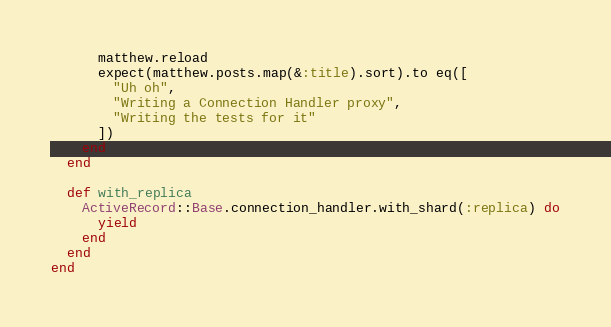<code> <loc_0><loc_0><loc_500><loc_500><_Ruby_>      matthew.reload
      expect(matthew.posts.map(&:title).sort).to eq([
        "Uh oh",
        "Writing a Connection Handler proxy",
        "Writing the tests for it"
      ])
    end
  end

  def with_replica
    ActiveRecord::Base.connection_handler.with_shard(:replica) do
      yield
    end
  end
end
</code> 